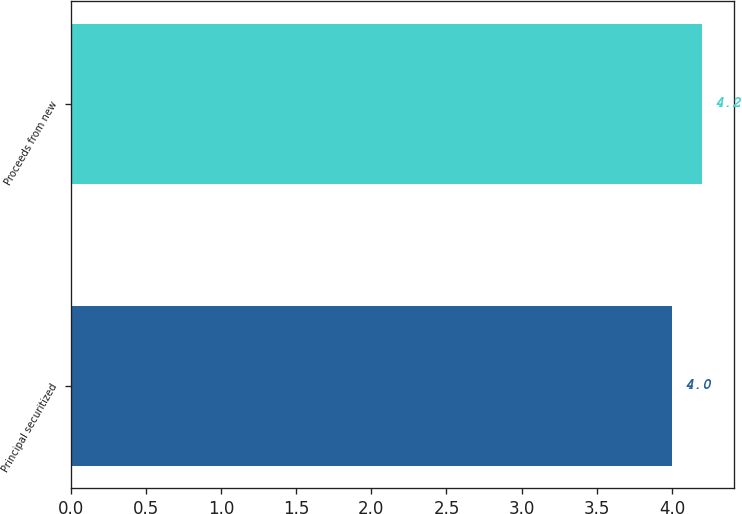<chart> <loc_0><loc_0><loc_500><loc_500><bar_chart><fcel>Principal securitized<fcel>Proceeds from new<nl><fcel>4<fcel>4.2<nl></chart> 